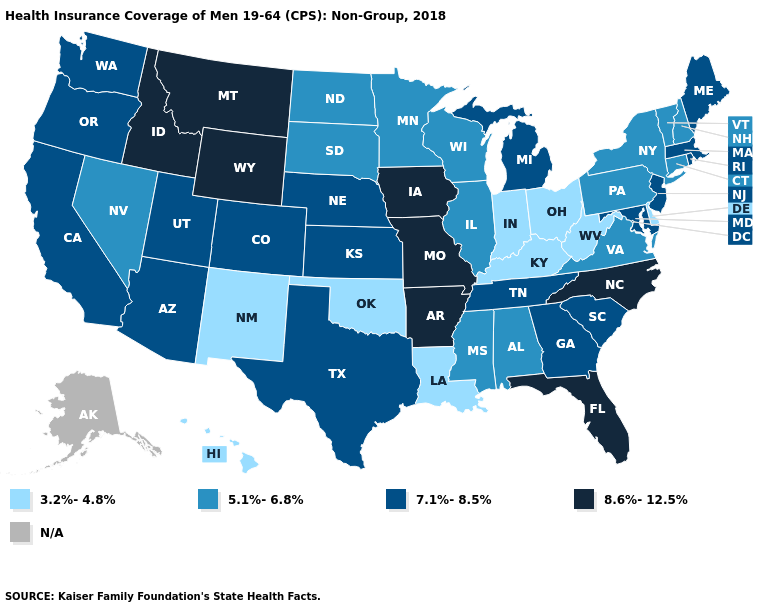What is the lowest value in the USA?
Quick response, please. 3.2%-4.8%. Name the states that have a value in the range 8.6%-12.5%?
Give a very brief answer. Arkansas, Florida, Idaho, Iowa, Missouri, Montana, North Carolina, Wyoming. Name the states that have a value in the range 3.2%-4.8%?
Be succinct. Delaware, Hawaii, Indiana, Kentucky, Louisiana, New Mexico, Ohio, Oklahoma, West Virginia. What is the value of Maryland?
Write a very short answer. 7.1%-8.5%. What is the value of North Carolina?
Short answer required. 8.6%-12.5%. What is the highest value in the USA?
Concise answer only. 8.6%-12.5%. Which states have the highest value in the USA?
Give a very brief answer. Arkansas, Florida, Idaho, Iowa, Missouri, Montana, North Carolina, Wyoming. Among the states that border Kansas , which have the lowest value?
Be succinct. Oklahoma. What is the value of Mississippi?
Concise answer only. 5.1%-6.8%. Name the states that have a value in the range N/A?
Answer briefly. Alaska. What is the highest value in the USA?
Concise answer only. 8.6%-12.5%. Is the legend a continuous bar?
Concise answer only. No. Does the first symbol in the legend represent the smallest category?
Concise answer only. Yes. Does Missouri have the highest value in the MidWest?
Answer briefly. Yes. 